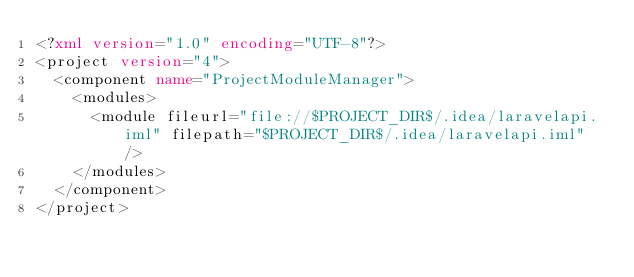Convert code to text. <code><loc_0><loc_0><loc_500><loc_500><_XML_><?xml version="1.0" encoding="UTF-8"?>
<project version="4">
  <component name="ProjectModuleManager">
    <modules>
      <module fileurl="file://$PROJECT_DIR$/.idea/laravelapi.iml" filepath="$PROJECT_DIR$/.idea/laravelapi.iml" />
    </modules>
  </component>
</project>

</code> 